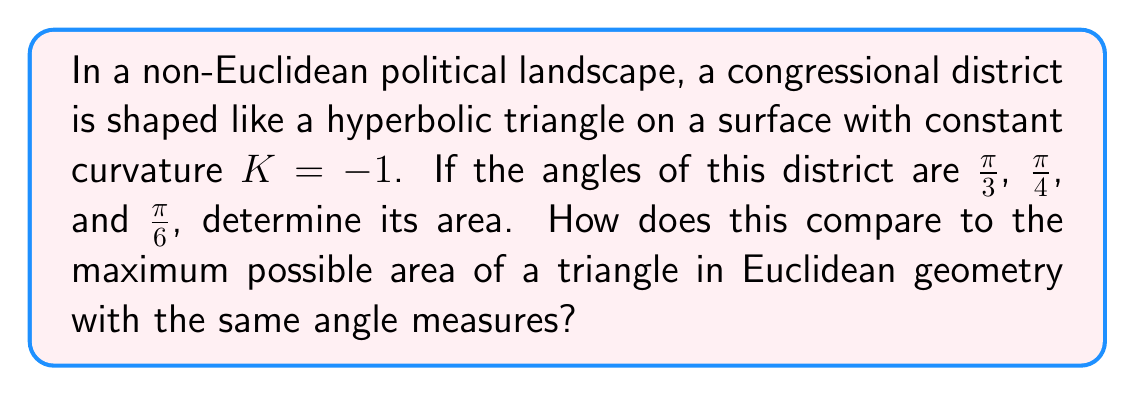Solve this math problem. Let's approach this step-by-step:

1) In hyperbolic geometry, the area of a triangle is given by the Gauss-Bonnet formula:

   $$A = \pi - (\alpha + \beta + \gamma) + |K|A$$

   where $A$ is the area, $\alpha$, $\beta$, and $\gamma$ are the angles, and $K$ is the curvature.

2) We're given that $K = -1$, so $|K| = 1$. Let's substitute the angles:

   $$A = \pi - (\frac{\pi}{3} + \frac{\pi}{4} + \frac{\pi}{6}) + A$$

3) Simplify the angle sum:

   $$A = \pi - (\frac{4\pi}{12} + \frac{3\pi}{12} + \frac{2\pi}{12}) + A = \pi - \frac{9\pi}{12} + A$$

4) Simplify further:

   $$A = \frac{3\pi}{12} + A$$

5) Subtract $A$ from both sides:

   $$0 = \frac{3\pi}{12}$$

6) Therefore, the area of the hyperbolic triangle is:

   $$A = \frac{3\pi}{12} = \frac{\pi}{4}$$

7) In Euclidean geometry, the sum of angles in a triangle is always $\pi$, and the maximum area occurs when the triangle is equilateral. However, in this case, the sum of angles is less than $\pi$:

   $$\frac{\pi}{3} + \frac{\pi}{4} + \frac{\pi}{6} = \frac{9\pi}{12} < \pi$$

   This is impossible in Euclidean geometry, highlighting the unique properties of non-Euclidean spaces in political districting.
Answer: $\frac{\pi}{4}$ square units 